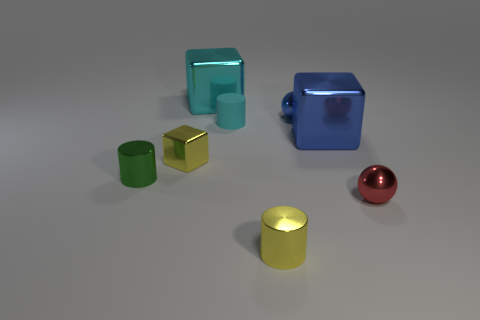Add 1 small red metallic things. How many objects exist? 9 Subtract all spheres. How many objects are left? 6 Subtract all tiny matte things. Subtract all green metal things. How many objects are left? 6 Add 6 blue metal blocks. How many blue metal blocks are left? 7 Add 4 large gray rubber cubes. How many large gray rubber cubes exist? 4 Subtract 0 green spheres. How many objects are left? 8 